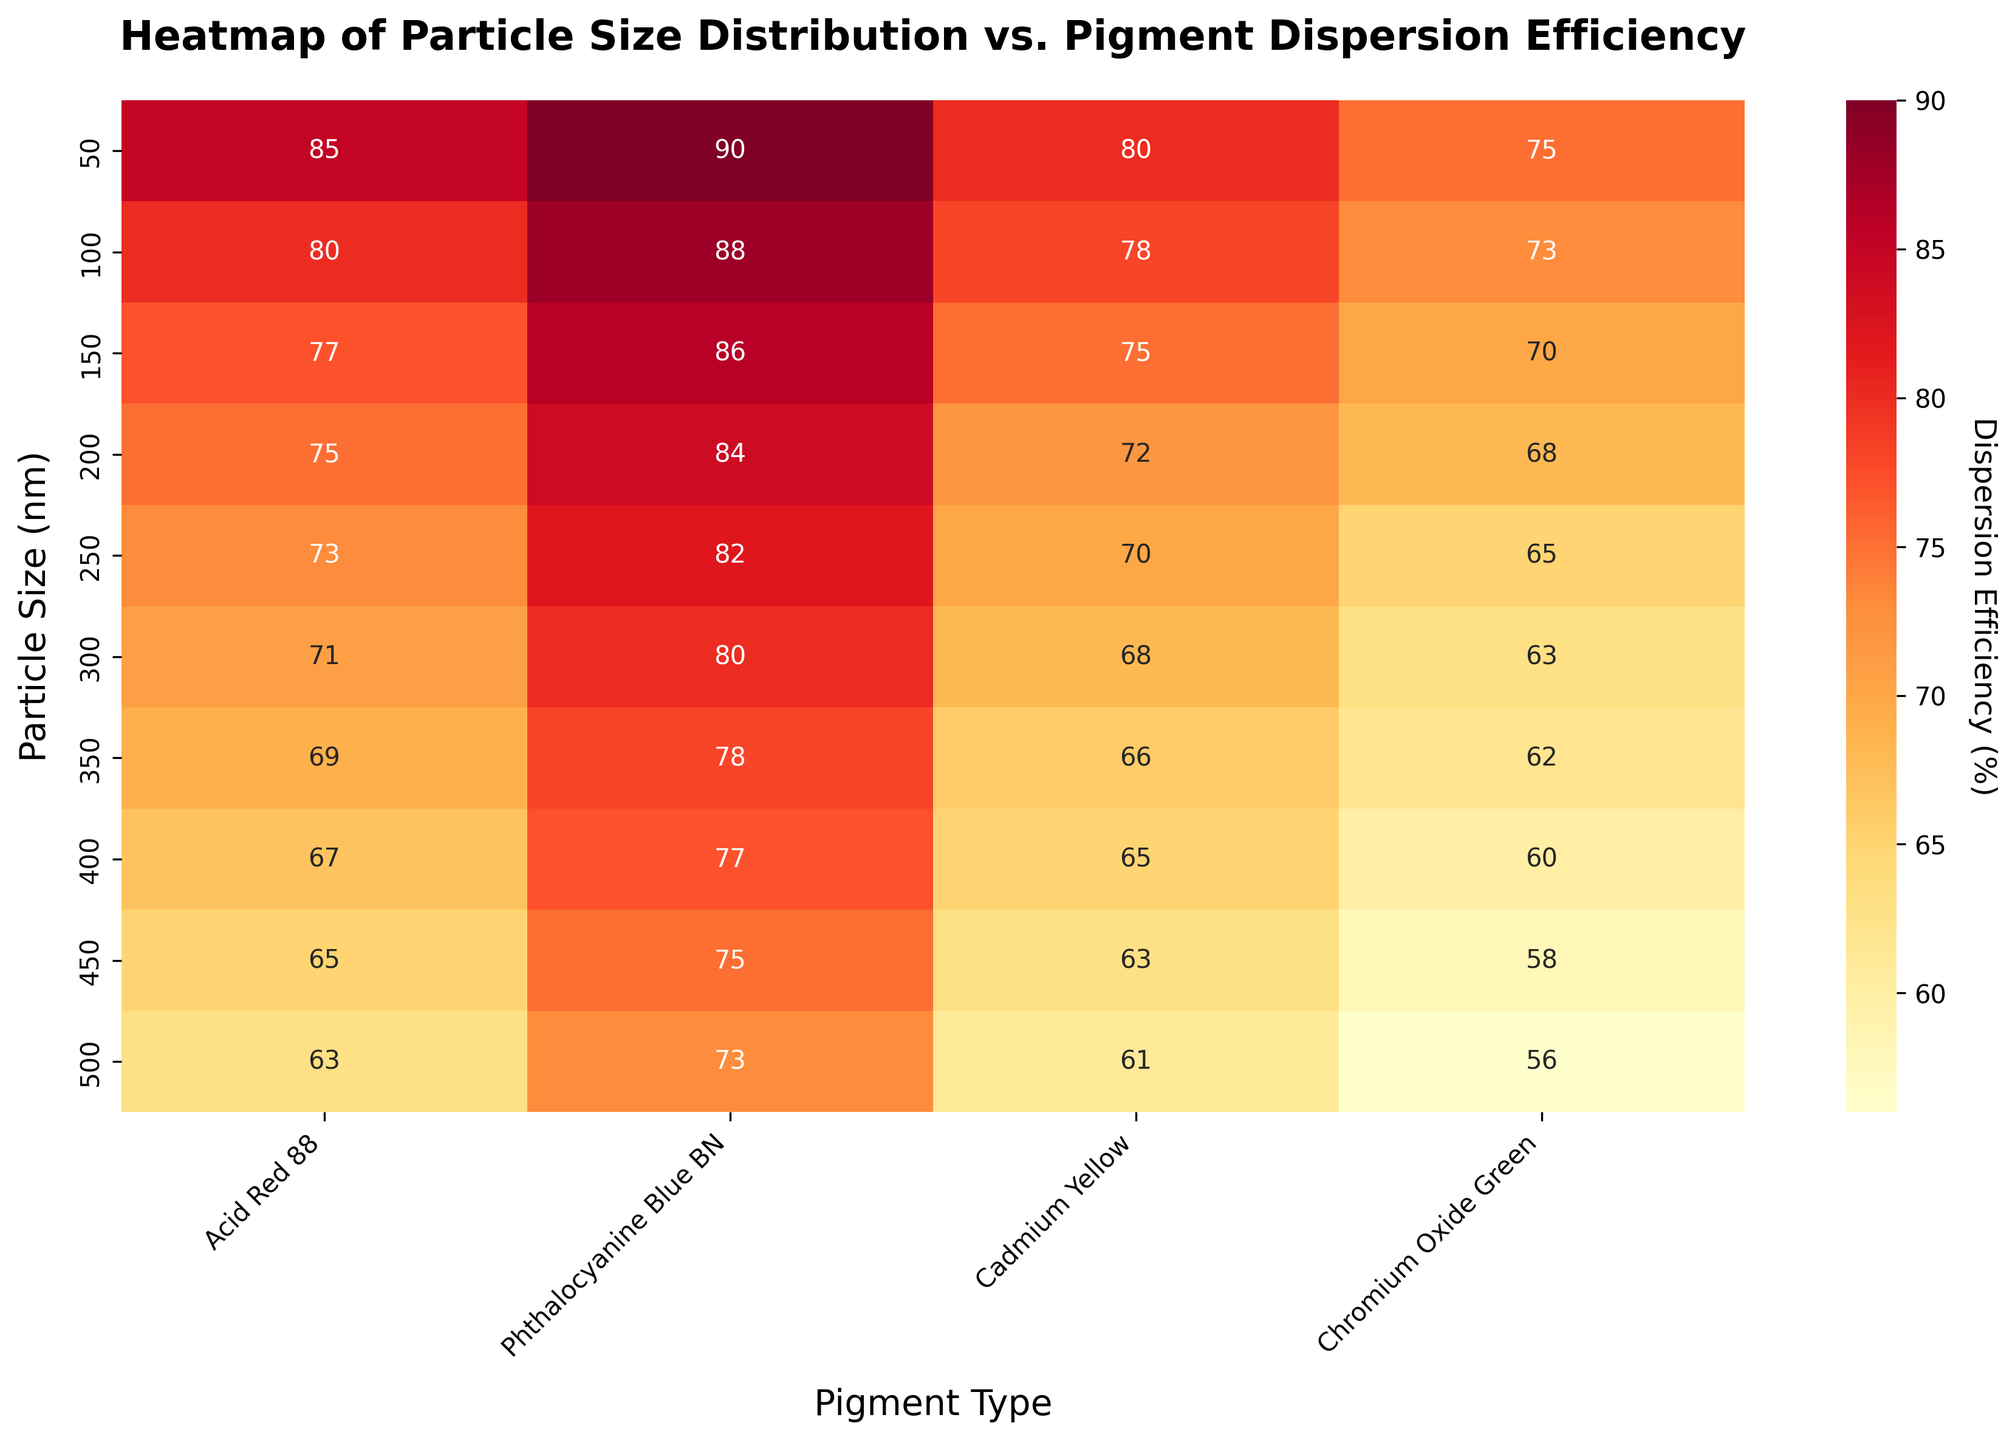What is the title of the heatmap? The title of the heatmap is written at the top of the plot. It reads "Heatmap of Particle Size Distribution vs. Pigment Dispersion Efficiency".
Answer: Heatmap of Particle Size Distribution vs. Pigment Dispersion Efficiency What does the x-axis represent? The x-axis of the heatmap is labeled "Pigment Type," which represents different pigments: Acid Red 88, Phthalocyanine Blue BN, Cadmium Yellow, and Chromium Oxide Green.
Answer: Pigment Type What particle size shows the highest dispersion efficiency for Phthalocyanine Blue BN? The highest efficiency for Phthalocyanine Blue BN is observed at the smallest particle size of 50 nm, which is 90%.
Answer: 50 nm Which pigment shows the lowest dispersion efficiency for the particle size of 500 nm? For the particle size of 500 nm, the lowest dispersion efficiency is seen for Chromium Oxide Green, which is 56%.
Answer: Chromium Oxide Green How does the dispersion efficiency of Acid Red 88 change as particle size increases from 50 nm to 500 nm? The dispersion efficiency of Acid Red 88 decreases as the particle size increases from 50 nm (85%) to 500 nm (63%). This is a downward trend.
Answer: Decreases What is the average dispersion efficiency of Cadmium Yellow across all particle sizes? To find the average dispersion efficiency of Cadmium Yellow, sum the efficiencies for all particle sizes and divide by the number of data points: (80 + 78 + 75 + 72 + 70 + 68 + 66 + 65 + 63 + 61) / 10 = 698 / 10.
Answer: 69.8% Which pigment has the smallest range of dispersion efficiencies across all particle sizes? Calculate the range for each pigment by finding the difference between the highest and lowest efficiencies across particle sizes: Acid Red 88 (85-63 = 22), Phthalocyanine Blue BN (90-73 = 17), Cadmium Yellow (80-61 = 19), Chromium Oxide Green (75-56 = 19). Phthalocyanine Blue BN has the smallest range of 17.
Answer: Phthalocyanine Blue BN Do any pigment dispersion efficiencies remain constant as the particle size changes? Check if any pigment has the same efficiency across all particle sizes. If all efficiencies are different, no pigment remains constant. All pigments show varying efficiencies, so none remain constant.
Answer: No For Chromium Oxide Green, what is the dispersion efficiency difference between the particle sizes of 50 nm and 250 nm? The dispersion efficiency for Chromium Oxide Green at 50 nm is 75% and at 250 nm is 65%. The difference is 75 - 65.
Answer: 10% What pattern do you observe for the dispersion efficiencies across the particle sizes? Observe all lines across the heatmap: Generally, the dispersion efficiency decreases as the particle size increases for all pigments, indicating an inverse relationship between particle size and dispersion efficiency.
Answer: Decreases 